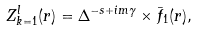<formula> <loc_0><loc_0><loc_500><loc_500>Z _ { k = 1 } ^ { l } ( r ) = \Delta ^ { - s + i m \gamma } \times \bar { f } _ { 1 } ( r ) ,</formula> 